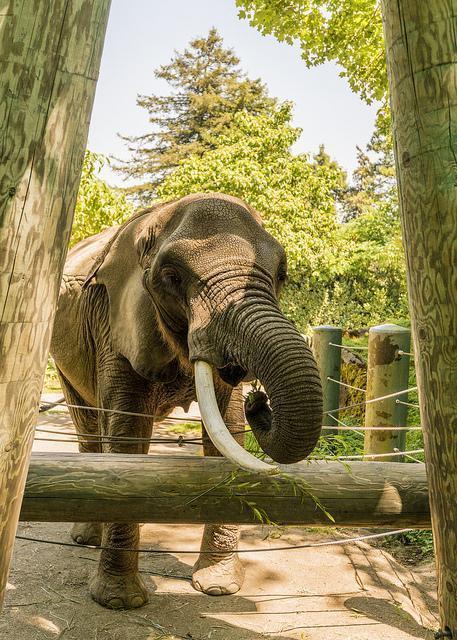How many of the chairs are blue?
Give a very brief answer. 0. 